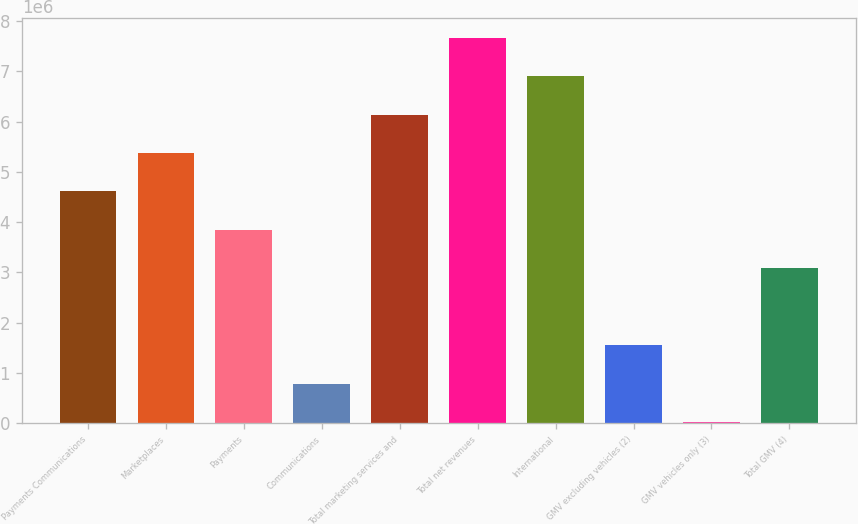Convert chart. <chart><loc_0><loc_0><loc_500><loc_500><bar_chart><fcel>Payments Communications<fcel>Marketplaces<fcel>Payments<fcel>Communications<fcel>Total marketing services and<fcel>Total net revenues<fcel>International<fcel>GMV excluding vehicles (2)<fcel>GMV vehicles only (3)<fcel>Total GMV (4)<nl><fcel>4.60851e+06<fcel>5.37446e+06<fcel>3.84255e+06<fcel>778734<fcel>6.14042e+06<fcel>7.67233e+06<fcel>6.90637e+06<fcel>1.54469e+06<fcel>12779<fcel>3.0766e+06<nl></chart> 